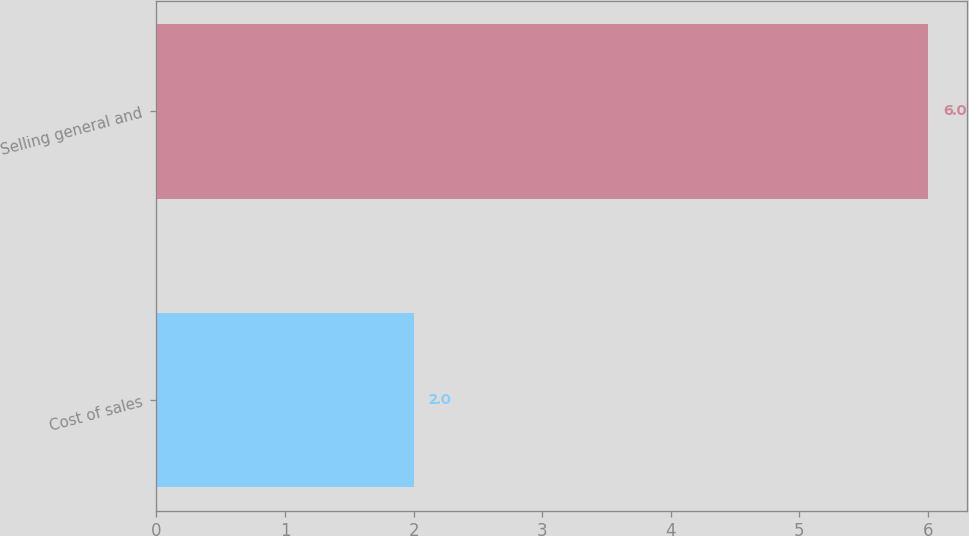<chart> <loc_0><loc_0><loc_500><loc_500><bar_chart><fcel>Cost of sales<fcel>Selling general and<nl><fcel>2<fcel>6<nl></chart> 